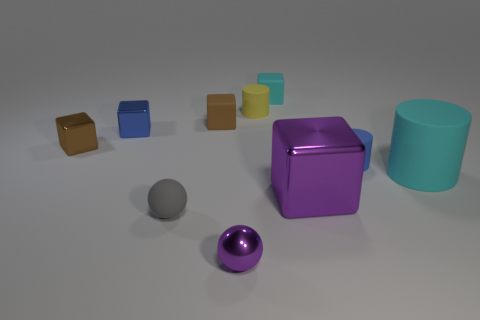What can you infer about the light source in this image? The light source seems to be placed above the objects, slightly off-center to the left. This observation is based on the shadows being cast to the lower right of the objects, indicating the light is coming from the upper left. 